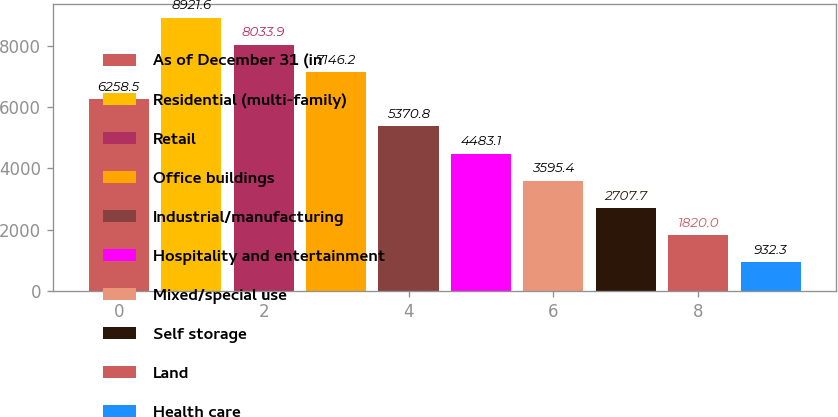<chart> <loc_0><loc_0><loc_500><loc_500><bar_chart><fcel>As of December 31 (in<fcel>Residential (multi-family)<fcel>Retail<fcel>Office buildings<fcel>Industrial/manufacturing<fcel>Hospitality and entertainment<fcel>Mixed/special use<fcel>Self storage<fcel>Land<fcel>Health care<nl><fcel>6258.5<fcel>8921.6<fcel>8033.9<fcel>7146.2<fcel>5370.8<fcel>4483.1<fcel>3595.4<fcel>2707.7<fcel>1820<fcel>932.3<nl></chart> 